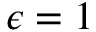<formula> <loc_0><loc_0><loc_500><loc_500>\epsilon = 1</formula> 